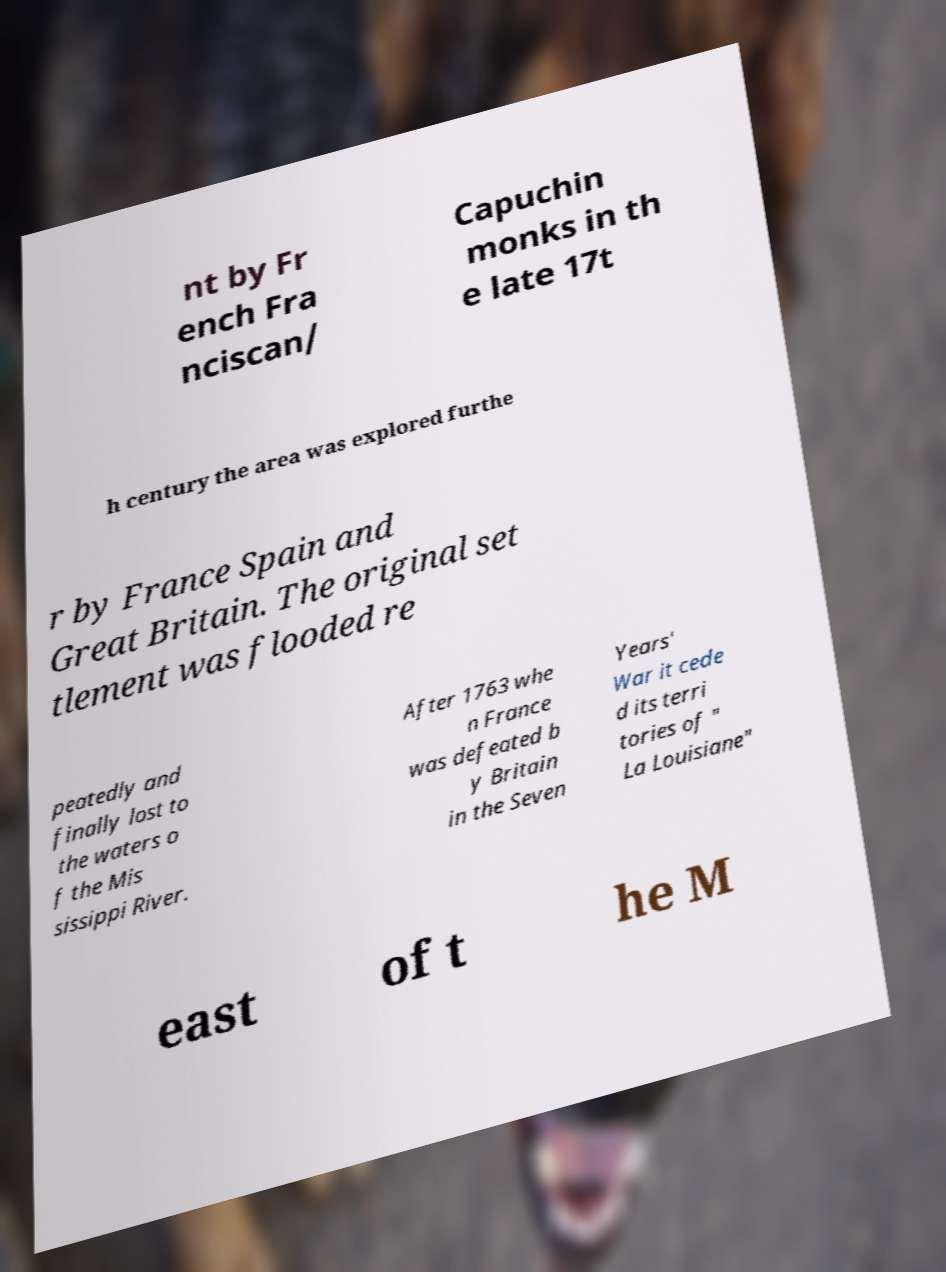I need the written content from this picture converted into text. Can you do that? nt by Fr ench Fra nciscan/ Capuchin monks in th e late 17t h century the area was explored furthe r by France Spain and Great Britain. The original set tlement was flooded re peatedly and finally lost to the waters o f the Mis sissippi River. After 1763 whe n France was defeated b y Britain in the Seven Years' War it cede d its terri tories of " La Louisiane" east of t he M 